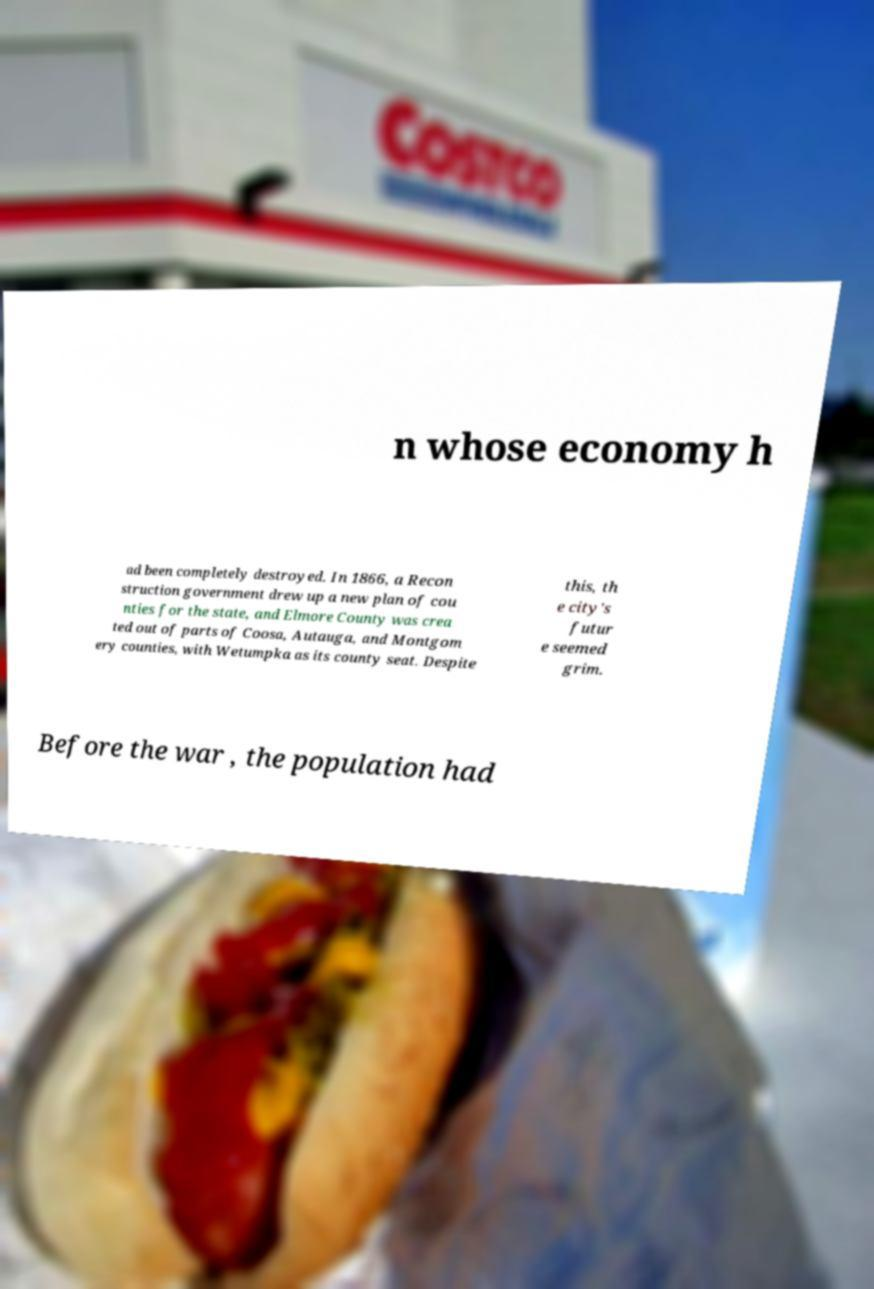Could you extract and type out the text from this image? n whose economy h ad been completely destroyed. In 1866, a Recon struction government drew up a new plan of cou nties for the state, and Elmore County was crea ted out of parts of Coosa, Autauga, and Montgom ery counties, with Wetumpka as its county seat. Despite this, th e city's futur e seemed grim. Before the war , the population had 